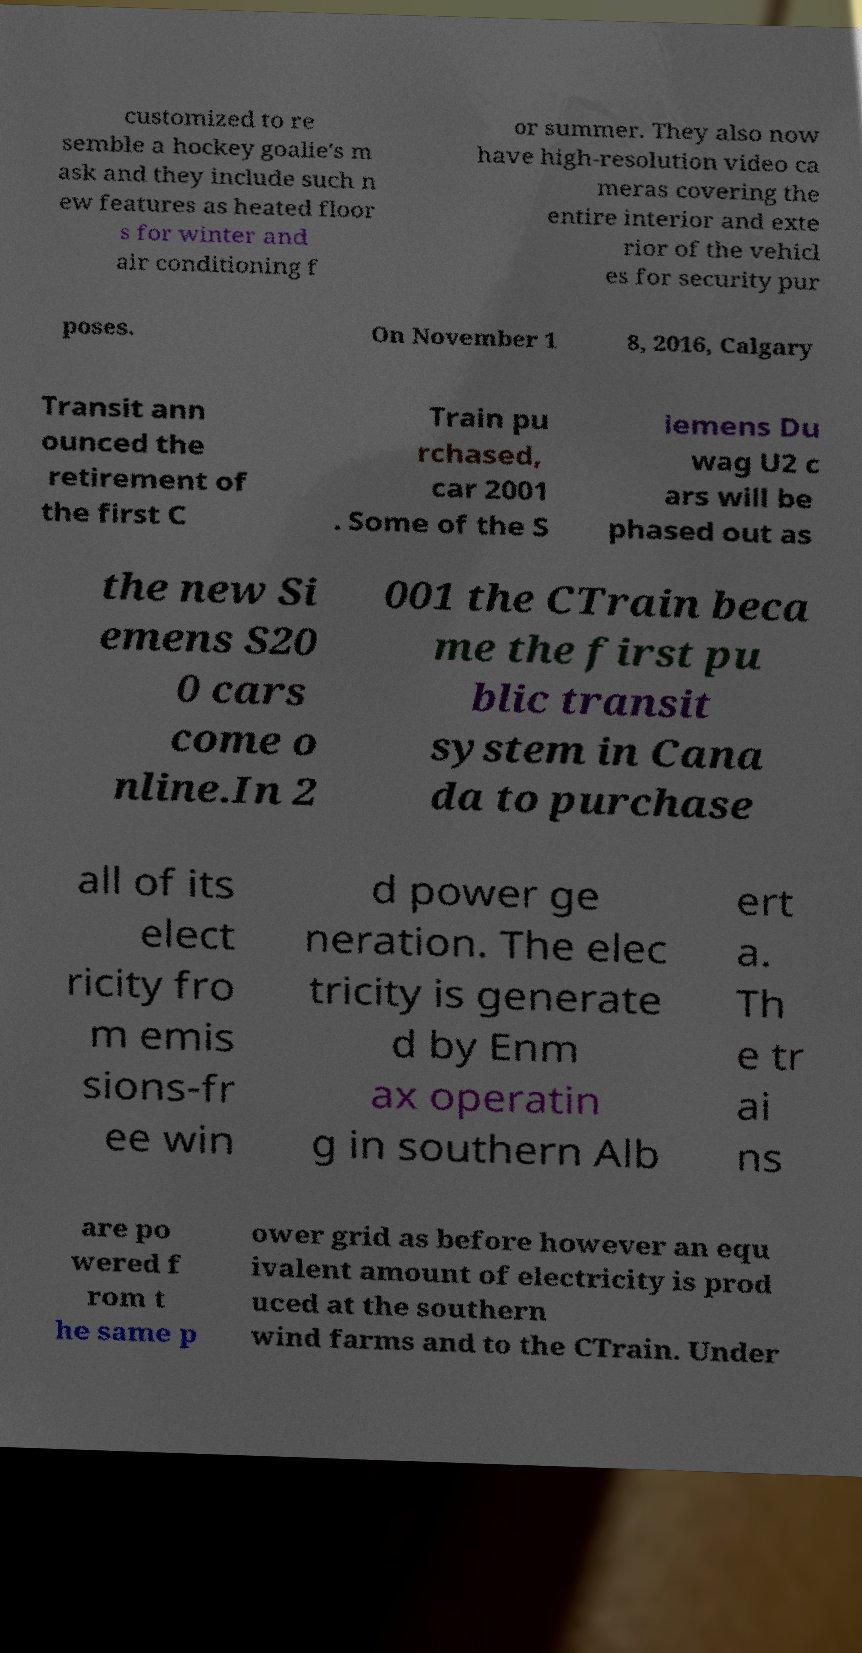Please identify and transcribe the text found in this image. customized to re semble a hockey goalie's m ask and they include such n ew features as heated floor s for winter and air conditioning f or summer. They also now have high-resolution video ca meras covering the entire interior and exte rior of the vehicl es for security pur poses. On November 1 8, 2016, Calgary Transit ann ounced the retirement of the first C Train pu rchased, car 2001 . Some of the S iemens Du wag U2 c ars will be phased out as the new Si emens S20 0 cars come o nline.In 2 001 the CTrain beca me the first pu blic transit system in Cana da to purchase all of its elect ricity fro m emis sions-fr ee win d power ge neration. The elec tricity is generate d by Enm ax operatin g in southern Alb ert a. Th e tr ai ns are po wered f rom t he same p ower grid as before however an equ ivalent amount of electricity is prod uced at the southern wind farms and to the CTrain. Under 